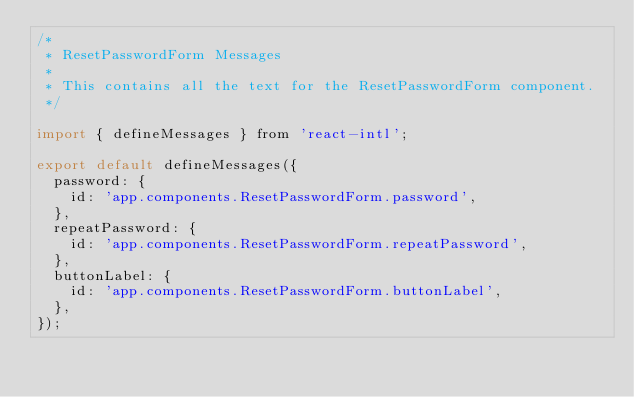Convert code to text. <code><loc_0><loc_0><loc_500><loc_500><_JavaScript_>/*
 * ResetPasswordForm Messages
 *
 * This contains all the text for the ResetPasswordForm component.
 */

import { defineMessages } from 'react-intl';

export default defineMessages({
  password: {
    id: 'app.components.ResetPasswordForm.password',
  },
  repeatPassword: {
    id: 'app.components.ResetPasswordForm.repeatPassword',
  },
  buttonLabel: {
    id: 'app.components.ResetPasswordForm.buttonLabel',
  },
});
</code> 